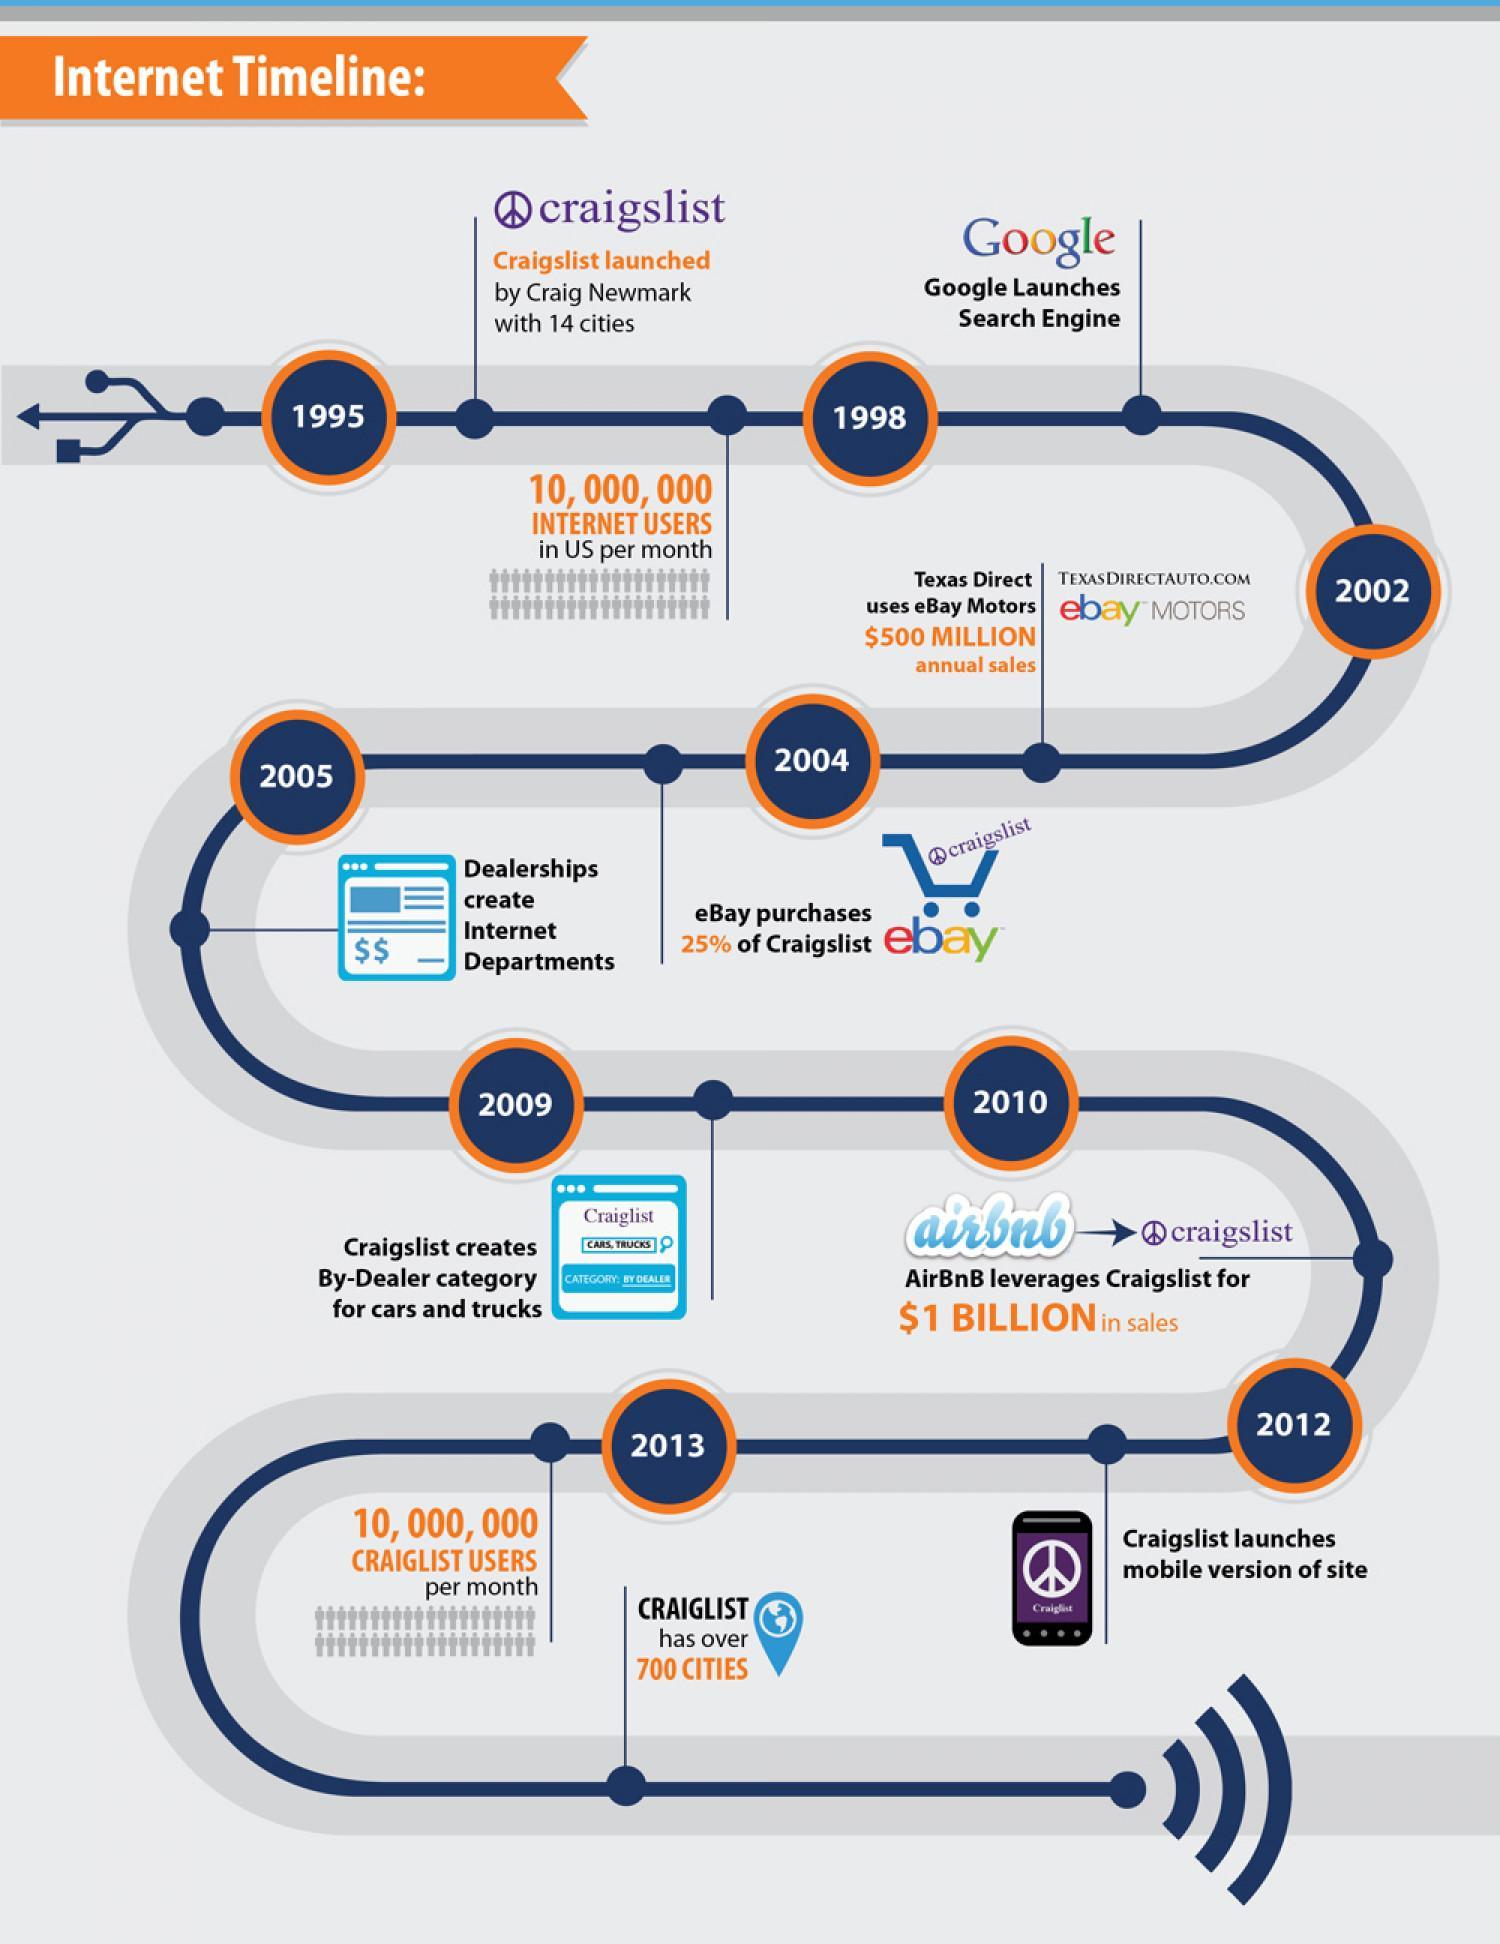What was the number of craigslist users per month in 2013?
Answer the question with a short phrase. 10,000,000 In which year was Google search engine launched? 1998 Who founded Craigslist? Craig Newmark Which seller made $500 million annual sales on ebay motors? Texas Direct In which year was Craigslist launched? 1995 In which year did ebay purchase 25% of Craigslist? 2004 As of 2013 how many cities are covered by Craigslist? 700 When was the mobile version of Craigslist website launched? 2012 In which year did Airbnb leverage Craigslist for $1bn in sales? 2010 what was the number of internet users per month in the US before 1998? 10,000,000 